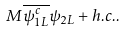<formula> <loc_0><loc_0><loc_500><loc_500>M { \overline { \psi _ { 1 L } ^ { c } } } \psi _ { 2 L } + h . c . .</formula> 